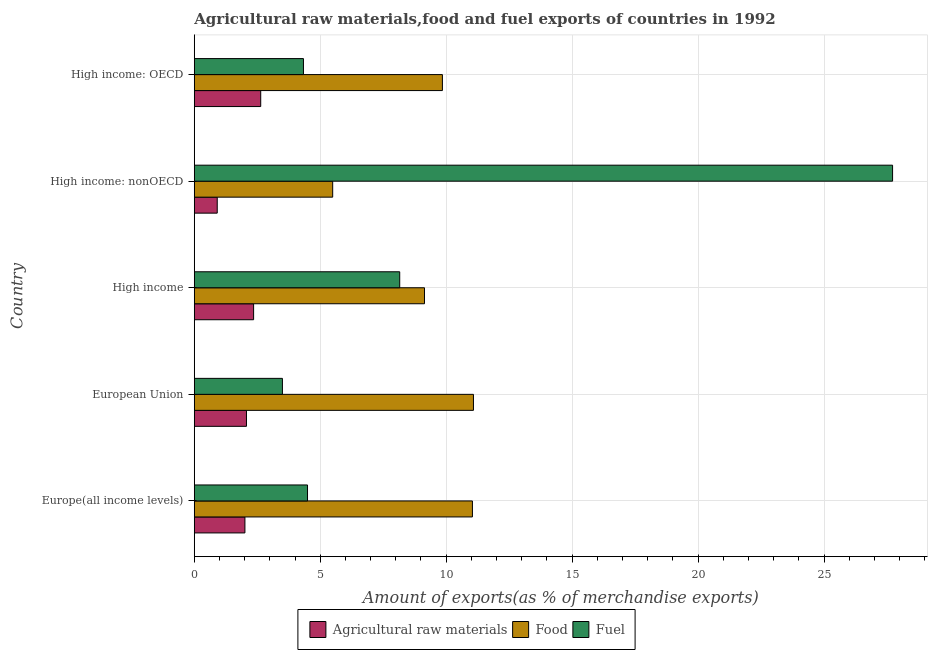How many groups of bars are there?
Your answer should be very brief. 5. Are the number of bars per tick equal to the number of legend labels?
Make the answer very short. Yes. How many bars are there on the 5th tick from the top?
Keep it short and to the point. 3. How many bars are there on the 4th tick from the bottom?
Give a very brief answer. 3. What is the label of the 4th group of bars from the top?
Ensure brevity in your answer.  European Union. In how many cases, is the number of bars for a given country not equal to the number of legend labels?
Your answer should be compact. 0. What is the percentage of raw materials exports in European Union?
Ensure brevity in your answer.  2.07. Across all countries, what is the maximum percentage of food exports?
Provide a short and direct response. 11.08. Across all countries, what is the minimum percentage of raw materials exports?
Offer a terse response. 0.91. In which country was the percentage of raw materials exports maximum?
Keep it short and to the point. High income: OECD. In which country was the percentage of raw materials exports minimum?
Your answer should be compact. High income: nonOECD. What is the total percentage of food exports in the graph?
Your response must be concise. 46.61. What is the difference between the percentage of raw materials exports in European Union and that in High income: OECD?
Provide a succinct answer. -0.57. What is the difference between the percentage of fuel exports in High income and the percentage of food exports in High income: nonOECD?
Keep it short and to the point. 2.66. What is the average percentage of food exports per country?
Offer a terse response. 9.32. What is the difference between the percentage of raw materials exports and percentage of fuel exports in Europe(all income levels)?
Offer a terse response. -2.48. In how many countries, is the percentage of fuel exports greater than 1 %?
Your answer should be very brief. 5. What is the ratio of the percentage of raw materials exports in High income to that in High income: nonOECD?
Ensure brevity in your answer.  2.58. Is the difference between the percentage of raw materials exports in High income: OECD and High income: nonOECD greater than the difference between the percentage of fuel exports in High income: OECD and High income: nonOECD?
Provide a succinct answer. Yes. What is the difference between the highest and the second highest percentage of food exports?
Provide a succinct answer. 0.04. What is the difference between the highest and the lowest percentage of fuel exports?
Make the answer very short. 24.22. In how many countries, is the percentage of fuel exports greater than the average percentage of fuel exports taken over all countries?
Ensure brevity in your answer.  1. What does the 3rd bar from the top in High income: OECD represents?
Provide a short and direct response. Agricultural raw materials. What does the 3rd bar from the bottom in European Union represents?
Provide a short and direct response. Fuel. How many countries are there in the graph?
Your answer should be compact. 5. What is the difference between two consecutive major ticks on the X-axis?
Ensure brevity in your answer.  5. Does the graph contain grids?
Your response must be concise. Yes. Where does the legend appear in the graph?
Give a very brief answer. Bottom center. How are the legend labels stacked?
Offer a terse response. Horizontal. What is the title of the graph?
Your answer should be very brief. Agricultural raw materials,food and fuel exports of countries in 1992. What is the label or title of the X-axis?
Offer a terse response. Amount of exports(as % of merchandise exports). What is the Amount of exports(as % of merchandise exports) of Agricultural raw materials in Europe(all income levels)?
Provide a short and direct response. 2.01. What is the Amount of exports(as % of merchandise exports) of Food in Europe(all income levels)?
Your answer should be compact. 11.04. What is the Amount of exports(as % of merchandise exports) of Fuel in Europe(all income levels)?
Offer a terse response. 4.5. What is the Amount of exports(as % of merchandise exports) in Agricultural raw materials in European Union?
Offer a very short reply. 2.07. What is the Amount of exports(as % of merchandise exports) in Food in European Union?
Make the answer very short. 11.08. What is the Amount of exports(as % of merchandise exports) of Fuel in European Union?
Make the answer very short. 3.5. What is the Amount of exports(as % of merchandise exports) in Agricultural raw materials in High income?
Your answer should be very brief. 2.36. What is the Amount of exports(as % of merchandise exports) in Food in High income?
Ensure brevity in your answer.  9.14. What is the Amount of exports(as % of merchandise exports) of Fuel in High income?
Give a very brief answer. 8.16. What is the Amount of exports(as % of merchandise exports) of Agricultural raw materials in High income: nonOECD?
Your answer should be compact. 0.91. What is the Amount of exports(as % of merchandise exports) in Food in High income: nonOECD?
Keep it short and to the point. 5.5. What is the Amount of exports(as % of merchandise exports) in Fuel in High income: nonOECD?
Offer a very short reply. 27.72. What is the Amount of exports(as % of merchandise exports) of Agricultural raw materials in High income: OECD?
Provide a short and direct response. 2.64. What is the Amount of exports(as % of merchandise exports) of Food in High income: OECD?
Provide a succinct answer. 9.85. What is the Amount of exports(as % of merchandise exports) of Fuel in High income: OECD?
Ensure brevity in your answer.  4.33. Across all countries, what is the maximum Amount of exports(as % of merchandise exports) of Agricultural raw materials?
Offer a terse response. 2.64. Across all countries, what is the maximum Amount of exports(as % of merchandise exports) in Food?
Keep it short and to the point. 11.08. Across all countries, what is the maximum Amount of exports(as % of merchandise exports) of Fuel?
Ensure brevity in your answer.  27.72. Across all countries, what is the minimum Amount of exports(as % of merchandise exports) in Agricultural raw materials?
Give a very brief answer. 0.91. Across all countries, what is the minimum Amount of exports(as % of merchandise exports) in Food?
Provide a succinct answer. 5.5. Across all countries, what is the minimum Amount of exports(as % of merchandise exports) of Fuel?
Make the answer very short. 3.5. What is the total Amount of exports(as % of merchandise exports) in Agricultural raw materials in the graph?
Give a very brief answer. 9.99. What is the total Amount of exports(as % of merchandise exports) of Food in the graph?
Your answer should be very brief. 46.61. What is the total Amount of exports(as % of merchandise exports) in Fuel in the graph?
Keep it short and to the point. 48.21. What is the difference between the Amount of exports(as % of merchandise exports) in Agricultural raw materials in Europe(all income levels) and that in European Union?
Offer a very short reply. -0.06. What is the difference between the Amount of exports(as % of merchandise exports) in Food in Europe(all income levels) and that in European Union?
Your answer should be very brief. -0.04. What is the difference between the Amount of exports(as % of merchandise exports) in Fuel in Europe(all income levels) and that in European Union?
Provide a succinct answer. 1. What is the difference between the Amount of exports(as % of merchandise exports) of Agricultural raw materials in Europe(all income levels) and that in High income?
Provide a succinct answer. -0.34. What is the difference between the Amount of exports(as % of merchandise exports) in Food in Europe(all income levels) and that in High income?
Ensure brevity in your answer.  1.9. What is the difference between the Amount of exports(as % of merchandise exports) of Fuel in Europe(all income levels) and that in High income?
Offer a very short reply. -3.66. What is the difference between the Amount of exports(as % of merchandise exports) in Agricultural raw materials in Europe(all income levels) and that in High income: nonOECD?
Offer a terse response. 1.1. What is the difference between the Amount of exports(as % of merchandise exports) of Food in Europe(all income levels) and that in High income: nonOECD?
Offer a terse response. 5.55. What is the difference between the Amount of exports(as % of merchandise exports) of Fuel in Europe(all income levels) and that in High income: nonOECD?
Provide a short and direct response. -23.23. What is the difference between the Amount of exports(as % of merchandise exports) in Agricultural raw materials in Europe(all income levels) and that in High income: OECD?
Offer a terse response. -0.63. What is the difference between the Amount of exports(as % of merchandise exports) of Food in Europe(all income levels) and that in High income: OECD?
Provide a succinct answer. 1.19. What is the difference between the Amount of exports(as % of merchandise exports) of Fuel in Europe(all income levels) and that in High income: OECD?
Provide a short and direct response. 0.16. What is the difference between the Amount of exports(as % of merchandise exports) of Agricultural raw materials in European Union and that in High income?
Keep it short and to the point. -0.28. What is the difference between the Amount of exports(as % of merchandise exports) in Food in European Union and that in High income?
Your answer should be compact. 1.94. What is the difference between the Amount of exports(as % of merchandise exports) in Fuel in European Union and that in High income?
Ensure brevity in your answer.  -4.66. What is the difference between the Amount of exports(as % of merchandise exports) in Agricultural raw materials in European Union and that in High income: nonOECD?
Your answer should be compact. 1.16. What is the difference between the Amount of exports(as % of merchandise exports) in Food in European Union and that in High income: nonOECD?
Keep it short and to the point. 5.59. What is the difference between the Amount of exports(as % of merchandise exports) in Fuel in European Union and that in High income: nonOECD?
Your response must be concise. -24.22. What is the difference between the Amount of exports(as % of merchandise exports) of Agricultural raw materials in European Union and that in High income: OECD?
Give a very brief answer. -0.57. What is the difference between the Amount of exports(as % of merchandise exports) of Food in European Union and that in High income: OECD?
Offer a terse response. 1.23. What is the difference between the Amount of exports(as % of merchandise exports) of Fuel in European Union and that in High income: OECD?
Offer a very short reply. -0.84. What is the difference between the Amount of exports(as % of merchandise exports) in Agricultural raw materials in High income and that in High income: nonOECD?
Make the answer very short. 1.44. What is the difference between the Amount of exports(as % of merchandise exports) of Food in High income and that in High income: nonOECD?
Give a very brief answer. 3.64. What is the difference between the Amount of exports(as % of merchandise exports) of Fuel in High income and that in High income: nonOECD?
Keep it short and to the point. -19.57. What is the difference between the Amount of exports(as % of merchandise exports) in Agricultural raw materials in High income and that in High income: OECD?
Offer a very short reply. -0.28. What is the difference between the Amount of exports(as % of merchandise exports) of Food in High income and that in High income: OECD?
Your answer should be compact. -0.71. What is the difference between the Amount of exports(as % of merchandise exports) in Fuel in High income and that in High income: OECD?
Offer a very short reply. 3.82. What is the difference between the Amount of exports(as % of merchandise exports) of Agricultural raw materials in High income: nonOECD and that in High income: OECD?
Provide a succinct answer. -1.73. What is the difference between the Amount of exports(as % of merchandise exports) in Food in High income: nonOECD and that in High income: OECD?
Your answer should be very brief. -4.36. What is the difference between the Amount of exports(as % of merchandise exports) of Fuel in High income: nonOECD and that in High income: OECD?
Offer a very short reply. 23.39. What is the difference between the Amount of exports(as % of merchandise exports) in Agricultural raw materials in Europe(all income levels) and the Amount of exports(as % of merchandise exports) in Food in European Union?
Your answer should be compact. -9.07. What is the difference between the Amount of exports(as % of merchandise exports) of Agricultural raw materials in Europe(all income levels) and the Amount of exports(as % of merchandise exports) of Fuel in European Union?
Provide a short and direct response. -1.49. What is the difference between the Amount of exports(as % of merchandise exports) in Food in Europe(all income levels) and the Amount of exports(as % of merchandise exports) in Fuel in European Union?
Keep it short and to the point. 7.54. What is the difference between the Amount of exports(as % of merchandise exports) in Agricultural raw materials in Europe(all income levels) and the Amount of exports(as % of merchandise exports) in Food in High income?
Your answer should be very brief. -7.13. What is the difference between the Amount of exports(as % of merchandise exports) of Agricultural raw materials in Europe(all income levels) and the Amount of exports(as % of merchandise exports) of Fuel in High income?
Make the answer very short. -6.14. What is the difference between the Amount of exports(as % of merchandise exports) of Food in Europe(all income levels) and the Amount of exports(as % of merchandise exports) of Fuel in High income?
Your response must be concise. 2.89. What is the difference between the Amount of exports(as % of merchandise exports) of Agricultural raw materials in Europe(all income levels) and the Amount of exports(as % of merchandise exports) of Food in High income: nonOECD?
Keep it short and to the point. -3.48. What is the difference between the Amount of exports(as % of merchandise exports) in Agricultural raw materials in Europe(all income levels) and the Amount of exports(as % of merchandise exports) in Fuel in High income: nonOECD?
Provide a short and direct response. -25.71. What is the difference between the Amount of exports(as % of merchandise exports) of Food in Europe(all income levels) and the Amount of exports(as % of merchandise exports) of Fuel in High income: nonOECD?
Give a very brief answer. -16.68. What is the difference between the Amount of exports(as % of merchandise exports) in Agricultural raw materials in Europe(all income levels) and the Amount of exports(as % of merchandise exports) in Food in High income: OECD?
Your answer should be compact. -7.84. What is the difference between the Amount of exports(as % of merchandise exports) of Agricultural raw materials in Europe(all income levels) and the Amount of exports(as % of merchandise exports) of Fuel in High income: OECD?
Your answer should be very brief. -2.32. What is the difference between the Amount of exports(as % of merchandise exports) in Food in Europe(all income levels) and the Amount of exports(as % of merchandise exports) in Fuel in High income: OECD?
Provide a succinct answer. 6.71. What is the difference between the Amount of exports(as % of merchandise exports) of Agricultural raw materials in European Union and the Amount of exports(as % of merchandise exports) of Food in High income?
Offer a very short reply. -7.07. What is the difference between the Amount of exports(as % of merchandise exports) of Agricultural raw materials in European Union and the Amount of exports(as % of merchandise exports) of Fuel in High income?
Keep it short and to the point. -6.08. What is the difference between the Amount of exports(as % of merchandise exports) in Food in European Union and the Amount of exports(as % of merchandise exports) in Fuel in High income?
Offer a terse response. 2.93. What is the difference between the Amount of exports(as % of merchandise exports) of Agricultural raw materials in European Union and the Amount of exports(as % of merchandise exports) of Food in High income: nonOECD?
Make the answer very short. -3.42. What is the difference between the Amount of exports(as % of merchandise exports) in Agricultural raw materials in European Union and the Amount of exports(as % of merchandise exports) in Fuel in High income: nonOECD?
Offer a very short reply. -25.65. What is the difference between the Amount of exports(as % of merchandise exports) of Food in European Union and the Amount of exports(as % of merchandise exports) of Fuel in High income: nonOECD?
Offer a very short reply. -16.64. What is the difference between the Amount of exports(as % of merchandise exports) of Agricultural raw materials in European Union and the Amount of exports(as % of merchandise exports) of Food in High income: OECD?
Offer a very short reply. -7.78. What is the difference between the Amount of exports(as % of merchandise exports) in Agricultural raw materials in European Union and the Amount of exports(as % of merchandise exports) in Fuel in High income: OECD?
Provide a succinct answer. -2.26. What is the difference between the Amount of exports(as % of merchandise exports) of Food in European Union and the Amount of exports(as % of merchandise exports) of Fuel in High income: OECD?
Offer a terse response. 6.75. What is the difference between the Amount of exports(as % of merchandise exports) in Agricultural raw materials in High income and the Amount of exports(as % of merchandise exports) in Food in High income: nonOECD?
Your answer should be compact. -3.14. What is the difference between the Amount of exports(as % of merchandise exports) of Agricultural raw materials in High income and the Amount of exports(as % of merchandise exports) of Fuel in High income: nonOECD?
Offer a very short reply. -25.37. What is the difference between the Amount of exports(as % of merchandise exports) in Food in High income and the Amount of exports(as % of merchandise exports) in Fuel in High income: nonOECD?
Your answer should be very brief. -18.58. What is the difference between the Amount of exports(as % of merchandise exports) of Agricultural raw materials in High income and the Amount of exports(as % of merchandise exports) of Food in High income: OECD?
Provide a succinct answer. -7.5. What is the difference between the Amount of exports(as % of merchandise exports) in Agricultural raw materials in High income and the Amount of exports(as % of merchandise exports) in Fuel in High income: OECD?
Your answer should be compact. -1.98. What is the difference between the Amount of exports(as % of merchandise exports) in Food in High income and the Amount of exports(as % of merchandise exports) in Fuel in High income: OECD?
Provide a succinct answer. 4.8. What is the difference between the Amount of exports(as % of merchandise exports) in Agricultural raw materials in High income: nonOECD and the Amount of exports(as % of merchandise exports) in Food in High income: OECD?
Keep it short and to the point. -8.94. What is the difference between the Amount of exports(as % of merchandise exports) of Agricultural raw materials in High income: nonOECD and the Amount of exports(as % of merchandise exports) of Fuel in High income: OECD?
Your response must be concise. -3.42. What is the difference between the Amount of exports(as % of merchandise exports) in Food in High income: nonOECD and the Amount of exports(as % of merchandise exports) in Fuel in High income: OECD?
Provide a succinct answer. 1.16. What is the average Amount of exports(as % of merchandise exports) in Agricultural raw materials per country?
Your response must be concise. 2. What is the average Amount of exports(as % of merchandise exports) in Food per country?
Your answer should be compact. 9.32. What is the average Amount of exports(as % of merchandise exports) of Fuel per country?
Offer a very short reply. 9.64. What is the difference between the Amount of exports(as % of merchandise exports) in Agricultural raw materials and Amount of exports(as % of merchandise exports) in Food in Europe(all income levels)?
Provide a succinct answer. -9.03. What is the difference between the Amount of exports(as % of merchandise exports) in Agricultural raw materials and Amount of exports(as % of merchandise exports) in Fuel in Europe(all income levels)?
Provide a succinct answer. -2.48. What is the difference between the Amount of exports(as % of merchandise exports) in Food and Amount of exports(as % of merchandise exports) in Fuel in Europe(all income levels)?
Keep it short and to the point. 6.55. What is the difference between the Amount of exports(as % of merchandise exports) in Agricultural raw materials and Amount of exports(as % of merchandise exports) in Food in European Union?
Your answer should be very brief. -9.01. What is the difference between the Amount of exports(as % of merchandise exports) in Agricultural raw materials and Amount of exports(as % of merchandise exports) in Fuel in European Union?
Your response must be concise. -1.43. What is the difference between the Amount of exports(as % of merchandise exports) in Food and Amount of exports(as % of merchandise exports) in Fuel in European Union?
Keep it short and to the point. 7.58. What is the difference between the Amount of exports(as % of merchandise exports) of Agricultural raw materials and Amount of exports(as % of merchandise exports) of Food in High income?
Ensure brevity in your answer.  -6.78. What is the difference between the Amount of exports(as % of merchandise exports) in Agricultural raw materials and Amount of exports(as % of merchandise exports) in Fuel in High income?
Provide a succinct answer. -5.8. What is the difference between the Amount of exports(as % of merchandise exports) in Food and Amount of exports(as % of merchandise exports) in Fuel in High income?
Keep it short and to the point. 0.98. What is the difference between the Amount of exports(as % of merchandise exports) of Agricultural raw materials and Amount of exports(as % of merchandise exports) of Food in High income: nonOECD?
Your answer should be compact. -4.58. What is the difference between the Amount of exports(as % of merchandise exports) in Agricultural raw materials and Amount of exports(as % of merchandise exports) in Fuel in High income: nonOECD?
Give a very brief answer. -26.81. What is the difference between the Amount of exports(as % of merchandise exports) in Food and Amount of exports(as % of merchandise exports) in Fuel in High income: nonOECD?
Ensure brevity in your answer.  -22.23. What is the difference between the Amount of exports(as % of merchandise exports) of Agricultural raw materials and Amount of exports(as % of merchandise exports) of Food in High income: OECD?
Keep it short and to the point. -7.21. What is the difference between the Amount of exports(as % of merchandise exports) of Agricultural raw materials and Amount of exports(as % of merchandise exports) of Fuel in High income: OECD?
Keep it short and to the point. -1.7. What is the difference between the Amount of exports(as % of merchandise exports) in Food and Amount of exports(as % of merchandise exports) in Fuel in High income: OECD?
Your answer should be compact. 5.52. What is the ratio of the Amount of exports(as % of merchandise exports) of Agricultural raw materials in Europe(all income levels) to that in European Union?
Your response must be concise. 0.97. What is the ratio of the Amount of exports(as % of merchandise exports) of Food in Europe(all income levels) to that in European Union?
Your response must be concise. 1. What is the ratio of the Amount of exports(as % of merchandise exports) of Fuel in Europe(all income levels) to that in European Union?
Provide a succinct answer. 1.28. What is the ratio of the Amount of exports(as % of merchandise exports) in Agricultural raw materials in Europe(all income levels) to that in High income?
Your response must be concise. 0.85. What is the ratio of the Amount of exports(as % of merchandise exports) of Food in Europe(all income levels) to that in High income?
Your answer should be compact. 1.21. What is the ratio of the Amount of exports(as % of merchandise exports) of Fuel in Europe(all income levels) to that in High income?
Give a very brief answer. 0.55. What is the ratio of the Amount of exports(as % of merchandise exports) of Agricultural raw materials in Europe(all income levels) to that in High income: nonOECD?
Ensure brevity in your answer.  2.21. What is the ratio of the Amount of exports(as % of merchandise exports) in Food in Europe(all income levels) to that in High income: nonOECD?
Offer a terse response. 2.01. What is the ratio of the Amount of exports(as % of merchandise exports) of Fuel in Europe(all income levels) to that in High income: nonOECD?
Offer a very short reply. 0.16. What is the ratio of the Amount of exports(as % of merchandise exports) in Agricultural raw materials in Europe(all income levels) to that in High income: OECD?
Provide a short and direct response. 0.76. What is the ratio of the Amount of exports(as % of merchandise exports) in Food in Europe(all income levels) to that in High income: OECD?
Your answer should be very brief. 1.12. What is the ratio of the Amount of exports(as % of merchandise exports) of Fuel in Europe(all income levels) to that in High income: OECD?
Keep it short and to the point. 1.04. What is the ratio of the Amount of exports(as % of merchandise exports) in Agricultural raw materials in European Union to that in High income?
Make the answer very short. 0.88. What is the ratio of the Amount of exports(as % of merchandise exports) of Food in European Union to that in High income?
Offer a terse response. 1.21. What is the ratio of the Amount of exports(as % of merchandise exports) of Fuel in European Union to that in High income?
Ensure brevity in your answer.  0.43. What is the ratio of the Amount of exports(as % of merchandise exports) of Agricultural raw materials in European Union to that in High income: nonOECD?
Your response must be concise. 2.27. What is the ratio of the Amount of exports(as % of merchandise exports) in Food in European Union to that in High income: nonOECD?
Make the answer very short. 2.02. What is the ratio of the Amount of exports(as % of merchandise exports) of Fuel in European Union to that in High income: nonOECD?
Give a very brief answer. 0.13. What is the ratio of the Amount of exports(as % of merchandise exports) of Agricultural raw materials in European Union to that in High income: OECD?
Offer a terse response. 0.79. What is the ratio of the Amount of exports(as % of merchandise exports) of Food in European Union to that in High income: OECD?
Ensure brevity in your answer.  1.13. What is the ratio of the Amount of exports(as % of merchandise exports) in Fuel in European Union to that in High income: OECD?
Your answer should be compact. 0.81. What is the ratio of the Amount of exports(as % of merchandise exports) in Agricultural raw materials in High income to that in High income: nonOECD?
Offer a very short reply. 2.58. What is the ratio of the Amount of exports(as % of merchandise exports) of Food in High income to that in High income: nonOECD?
Offer a terse response. 1.66. What is the ratio of the Amount of exports(as % of merchandise exports) in Fuel in High income to that in High income: nonOECD?
Ensure brevity in your answer.  0.29. What is the ratio of the Amount of exports(as % of merchandise exports) in Agricultural raw materials in High income to that in High income: OECD?
Offer a very short reply. 0.89. What is the ratio of the Amount of exports(as % of merchandise exports) of Food in High income to that in High income: OECD?
Make the answer very short. 0.93. What is the ratio of the Amount of exports(as % of merchandise exports) of Fuel in High income to that in High income: OECD?
Keep it short and to the point. 1.88. What is the ratio of the Amount of exports(as % of merchandise exports) of Agricultural raw materials in High income: nonOECD to that in High income: OECD?
Keep it short and to the point. 0.35. What is the ratio of the Amount of exports(as % of merchandise exports) of Food in High income: nonOECD to that in High income: OECD?
Give a very brief answer. 0.56. What is the ratio of the Amount of exports(as % of merchandise exports) of Fuel in High income: nonOECD to that in High income: OECD?
Provide a short and direct response. 6.39. What is the difference between the highest and the second highest Amount of exports(as % of merchandise exports) in Agricultural raw materials?
Your answer should be very brief. 0.28. What is the difference between the highest and the second highest Amount of exports(as % of merchandise exports) of Food?
Your answer should be compact. 0.04. What is the difference between the highest and the second highest Amount of exports(as % of merchandise exports) of Fuel?
Give a very brief answer. 19.57. What is the difference between the highest and the lowest Amount of exports(as % of merchandise exports) in Agricultural raw materials?
Your answer should be very brief. 1.73. What is the difference between the highest and the lowest Amount of exports(as % of merchandise exports) of Food?
Ensure brevity in your answer.  5.59. What is the difference between the highest and the lowest Amount of exports(as % of merchandise exports) in Fuel?
Provide a succinct answer. 24.22. 